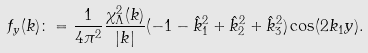<formula> <loc_0><loc_0><loc_500><loc_500>f _ { y } ( k ) \colon = \frac { 1 } { 4 \pi ^ { 2 } } \frac { \chi ^ { 2 } _ { \Lambda } ( k ) } { | k | } ( - 1 - \hat { k } _ { 1 } ^ { 2 } + \hat { k } _ { 2 } ^ { 2 } + \hat { k } _ { 3 } ^ { 2 } ) \cos ( 2 k _ { 1 } y ) .</formula> 